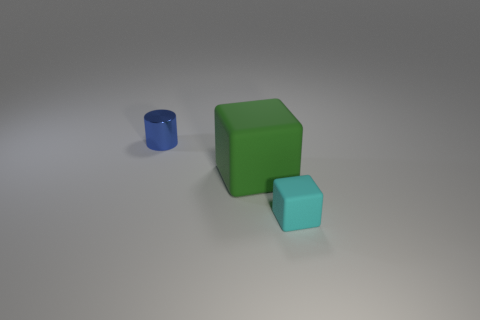Add 3 blue things. How many objects exist? 6 Subtract all green cubes. How many cubes are left? 1 Subtract all blocks. How many objects are left? 1 Subtract all cyan spheres. How many gray blocks are left? 0 Subtract all small yellow matte cylinders. Subtract all cyan matte things. How many objects are left? 2 Add 3 tiny objects. How many tiny objects are left? 5 Add 1 big blue shiny cylinders. How many big blue shiny cylinders exist? 1 Subtract 0 brown cubes. How many objects are left? 3 Subtract all gray cubes. Subtract all green cylinders. How many cubes are left? 2 